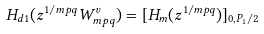Convert formula to latex. <formula><loc_0><loc_0><loc_500><loc_500>H _ { d 1 } ( z ^ { 1 / m p q } W _ { m p q } ^ { v } ) = [ { H } _ { m } ( z ^ { 1 / m p q } ) ] _ { 0 , P _ { 1 } / 2 }</formula> 